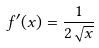Convert formula to latex. <formula><loc_0><loc_0><loc_500><loc_500>f ^ { \prime } ( x ) = \frac { 1 } { 2 \sqrt { x } }</formula> 